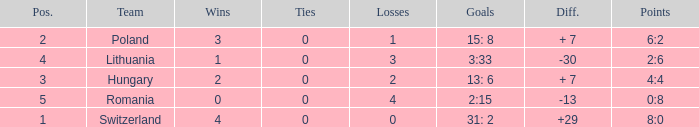Which team had under 2 losses and a placement number above 1? Poland. 